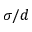Convert formula to latex. <formula><loc_0><loc_0><loc_500><loc_500>\sigma / d</formula> 